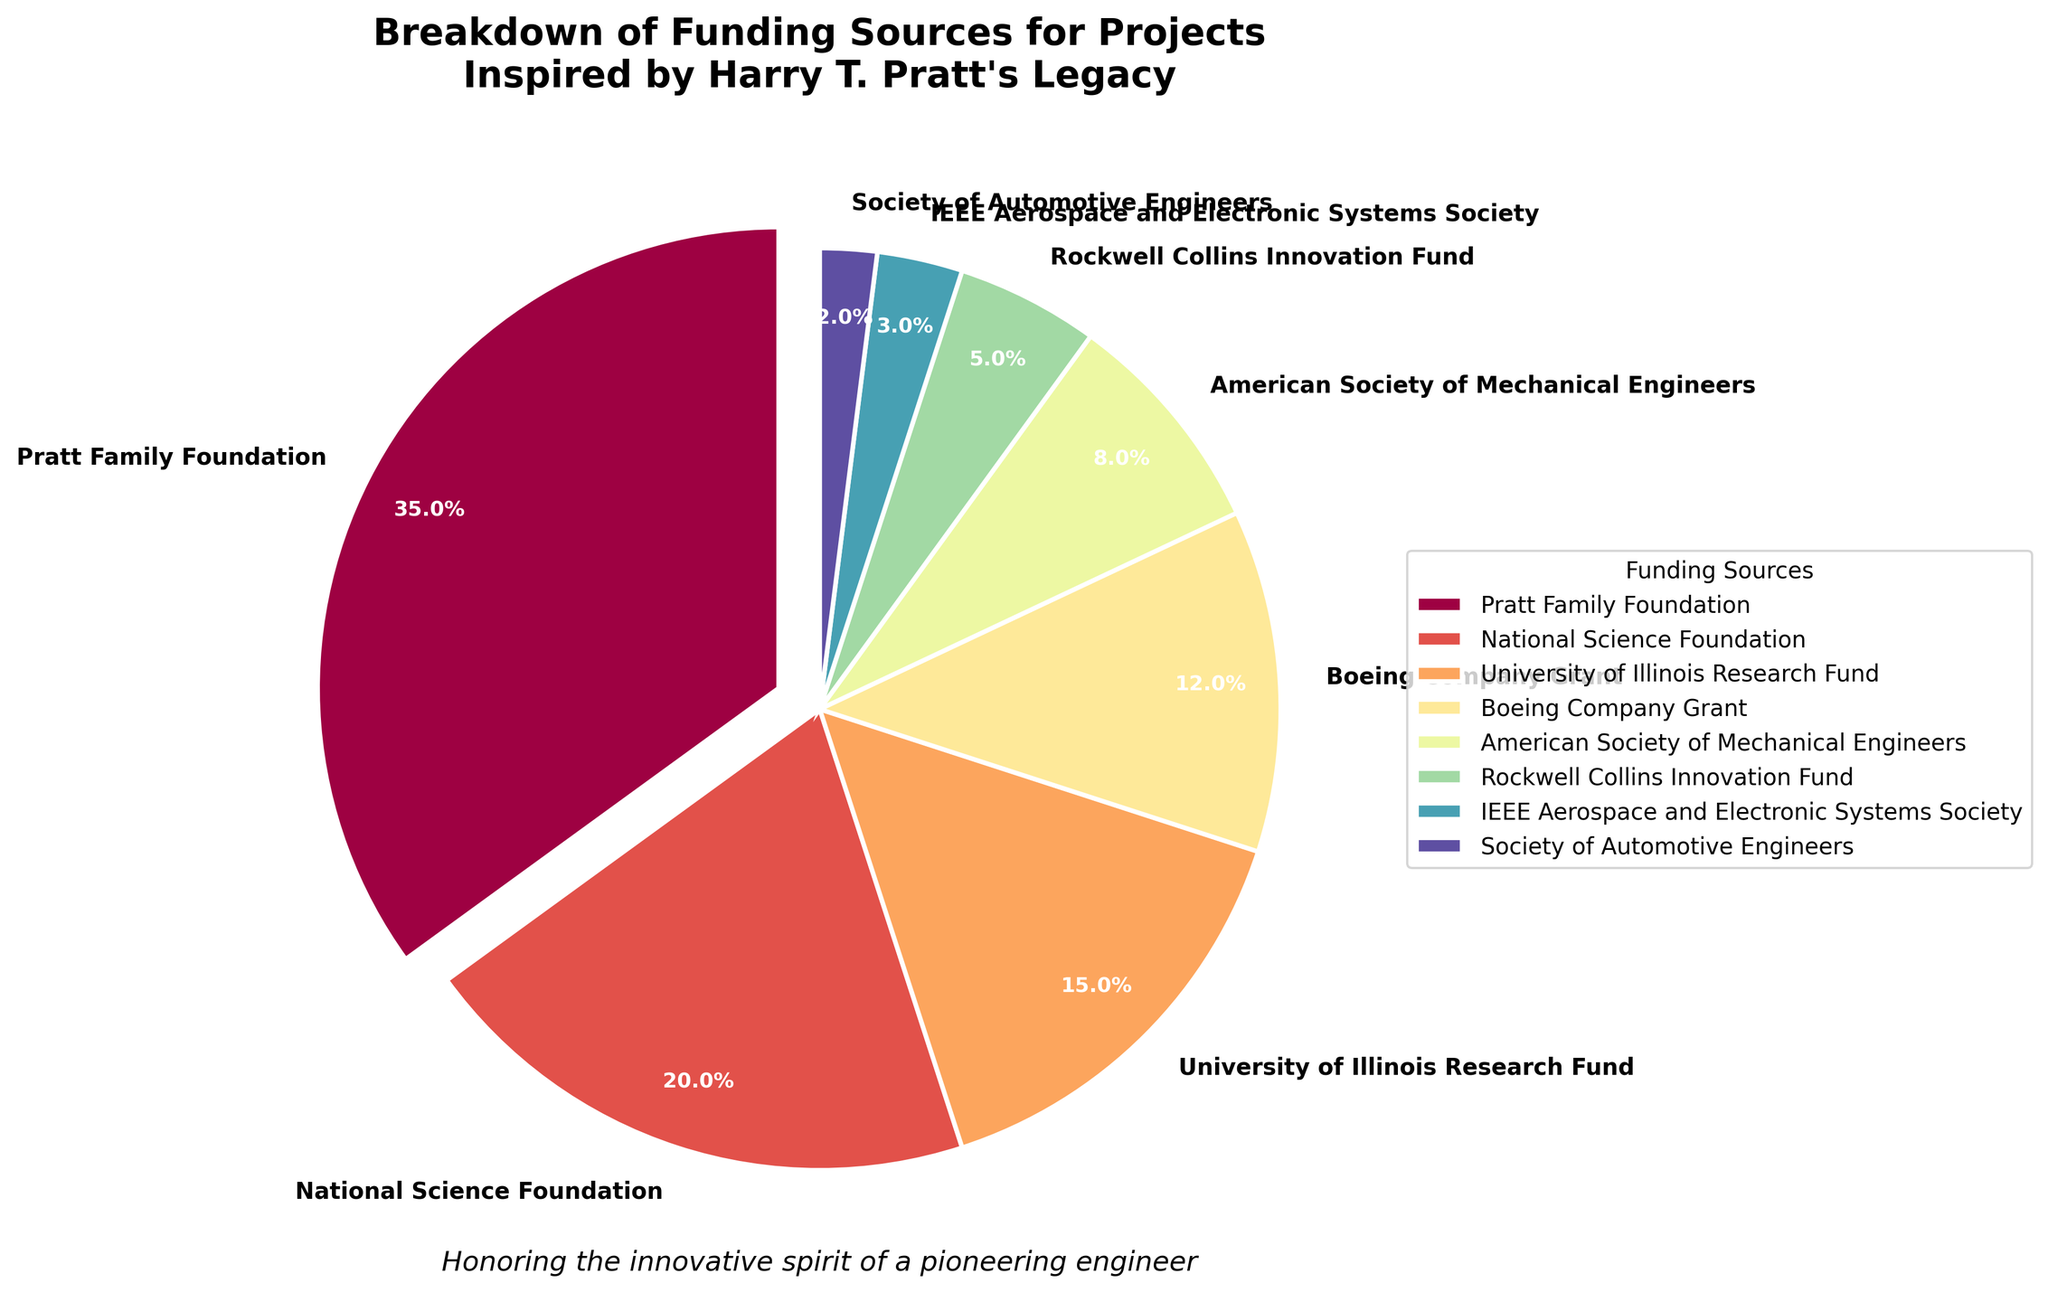Which funding source contributes the most? The pie chart shows that the largest segment belongs to the Pratt Family Foundation with 35%.
Answer: Pratt Family Foundation What is the combined percentage of funding from the National Science Foundation and the University of Illinois Research Fund? Sum up the percentages of both funding sources: 20% (National Science Foundation) + 15% (University of Illinois Research Fund) = 35%.
Answer: 35% Is funding from Boeing Company Grant greater than the sum of funding from the Society of Automotive Engineers and IEEE Aerospace and Electronic Systems Society? Compare the percentages: Boeing Company Grant has 12%, while Society of Automotive Engineers and IEEE Aerospace and Electronic Systems Society together have 2% + 3% = 5%, which is less than 12%.
Answer: Yes Which funding source has the smallest contribution? The smallest segment in the pie chart belongs to the Society of Automotive Engineers with 2%.
Answer: Society of Automotive Engineers What is the percentage difference between funding from the Pratt Family Foundation and American Society of Mechanical Engineers? Subtract the percentage of American Society of Mechanical Engineers from Pratt Family Foundation: 35% - 8% = 27%.
Answer: 27% What is the median funding percentage value? List all percentages in ascending order: 2%, 3%, 5%, 8%, 12%, 15%, 20%, 35%. The median is the average of the 4th and 5th values: (8% + 12%) / 2 = 10%.
Answer: 10% How does the percentage of funding from the American Society of Mechanical Engineers compare to that from Rockwell Collins Innovation Fund? Compare the percentages directly: American Society of Mechanical Engineers has 8%, while Rockwell Collins Innovation Fund has 5%. 8% is greater than 5%.
Answer: Greater What portion of the funding sources together make up more than half of the funding? Add the contribution percentages starting from the largest: 35% (Pratt Family Foundation) + 20% (National Science Foundation) = 55%. These two sources together make up more than half.
Answer: Pratt Family Foundation and National Science Foundation 